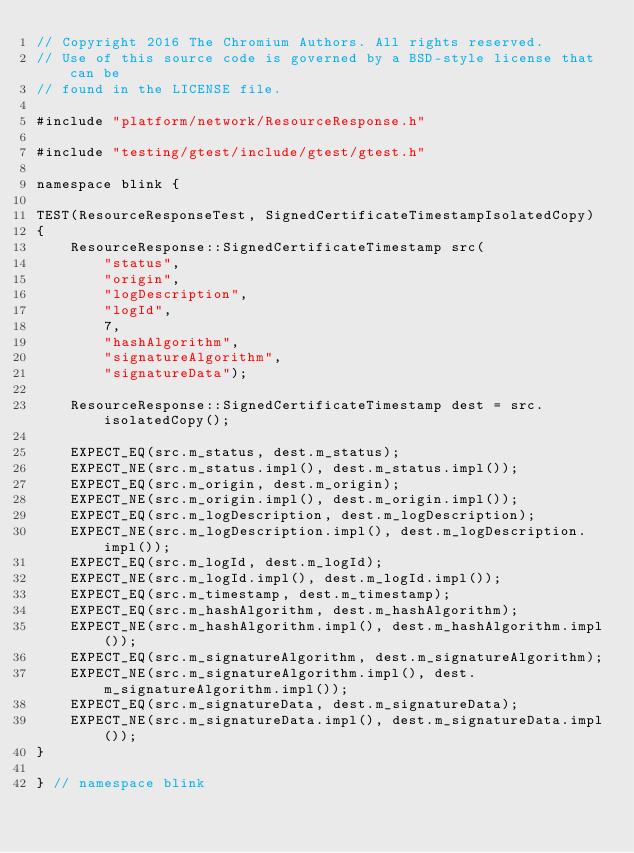<code> <loc_0><loc_0><loc_500><loc_500><_C++_>// Copyright 2016 The Chromium Authors. All rights reserved.
// Use of this source code is governed by a BSD-style license that can be
// found in the LICENSE file.

#include "platform/network/ResourceResponse.h"

#include "testing/gtest/include/gtest/gtest.h"

namespace blink {

TEST(ResourceResponseTest, SignedCertificateTimestampIsolatedCopy)
{
    ResourceResponse::SignedCertificateTimestamp src(
        "status",
        "origin",
        "logDescription",
        "logId",
        7,
        "hashAlgorithm",
        "signatureAlgorithm",
        "signatureData");

    ResourceResponse::SignedCertificateTimestamp dest = src.isolatedCopy();

    EXPECT_EQ(src.m_status, dest.m_status);
    EXPECT_NE(src.m_status.impl(), dest.m_status.impl());
    EXPECT_EQ(src.m_origin, dest.m_origin);
    EXPECT_NE(src.m_origin.impl(), dest.m_origin.impl());
    EXPECT_EQ(src.m_logDescription, dest.m_logDescription);
    EXPECT_NE(src.m_logDescription.impl(), dest.m_logDescription.impl());
    EXPECT_EQ(src.m_logId, dest.m_logId);
    EXPECT_NE(src.m_logId.impl(), dest.m_logId.impl());
    EXPECT_EQ(src.m_timestamp, dest.m_timestamp);
    EXPECT_EQ(src.m_hashAlgorithm, dest.m_hashAlgorithm);
    EXPECT_NE(src.m_hashAlgorithm.impl(), dest.m_hashAlgorithm.impl());
    EXPECT_EQ(src.m_signatureAlgorithm, dest.m_signatureAlgorithm);
    EXPECT_NE(src.m_signatureAlgorithm.impl(), dest.m_signatureAlgorithm.impl());
    EXPECT_EQ(src.m_signatureData, dest.m_signatureData);
    EXPECT_NE(src.m_signatureData.impl(), dest.m_signatureData.impl());
}

} // namespace blink
</code> 